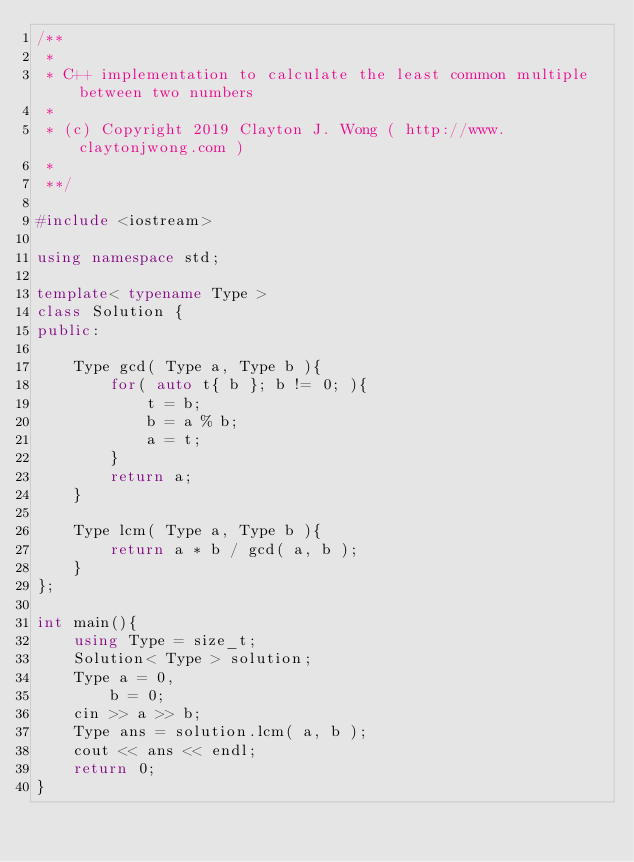Convert code to text. <code><loc_0><loc_0><loc_500><loc_500><_C++_>/**
 *
 * C++ implementation to calculate the least common multiple between two numbers
 *
 * (c) Copyright 2019 Clayton J. Wong ( http://www.claytonjwong.com )
 *
 **/

#include <iostream>

using namespace std;

template< typename Type >
class Solution {
public:

    Type gcd( Type a, Type b ){
        for( auto t{ b }; b != 0; ){
            t = b;
            b = a % b;
            a = t;
        }
        return a;
    }

    Type lcm( Type a, Type b ){
        return a * b / gcd( a, b );
    }
};

int main(){
    using Type = size_t;
    Solution< Type > solution;
    Type a = 0,
        b = 0;
    cin >> a >> b;
    Type ans = solution.lcm( a, b );
    cout << ans << endl;
    return 0;
}
</code> 